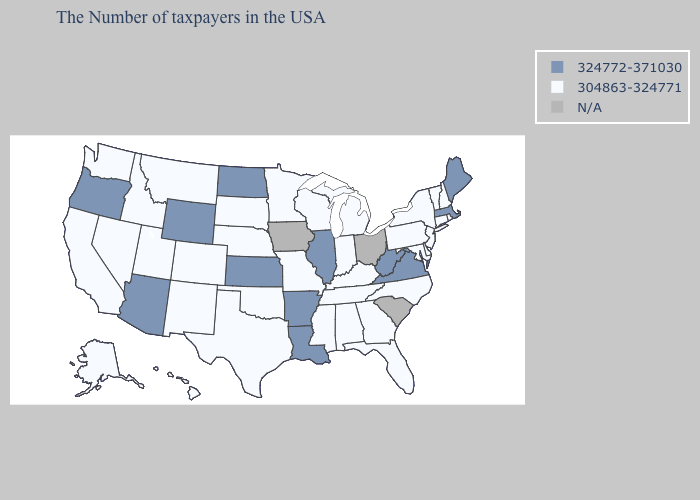Which states hav the highest value in the West?
Keep it brief. Wyoming, Arizona, Oregon. Does Maryland have the lowest value in the South?
Be succinct. Yes. Which states have the lowest value in the Northeast?
Quick response, please. Rhode Island, New Hampshire, Vermont, Connecticut, New York, New Jersey, Pennsylvania. Among the states that border Delaware , which have the highest value?
Concise answer only. New Jersey, Maryland, Pennsylvania. What is the value of Montana?
Quick response, please. 304863-324771. Is the legend a continuous bar?
Short answer required. No. What is the lowest value in the Northeast?
Quick response, please. 304863-324771. Among the states that border Texas , which have the highest value?
Short answer required. Louisiana, Arkansas. Name the states that have a value in the range 304863-324771?
Concise answer only. Rhode Island, New Hampshire, Vermont, Connecticut, New York, New Jersey, Delaware, Maryland, Pennsylvania, North Carolina, Florida, Georgia, Michigan, Kentucky, Indiana, Alabama, Tennessee, Wisconsin, Mississippi, Missouri, Minnesota, Nebraska, Oklahoma, Texas, South Dakota, Colorado, New Mexico, Utah, Montana, Idaho, Nevada, California, Washington, Alaska, Hawaii. Name the states that have a value in the range 324772-371030?
Answer briefly. Maine, Massachusetts, Virginia, West Virginia, Illinois, Louisiana, Arkansas, Kansas, North Dakota, Wyoming, Arizona, Oregon. What is the value of South Carolina?
Concise answer only. N/A. Does the first symbol in the legend represent the smallest category?
Concise answer only. No. Among the states that border Ohio , which have the lowest value?
Quick response, please. Pennsylvania, Michigan, Kentucky, Indiana. 